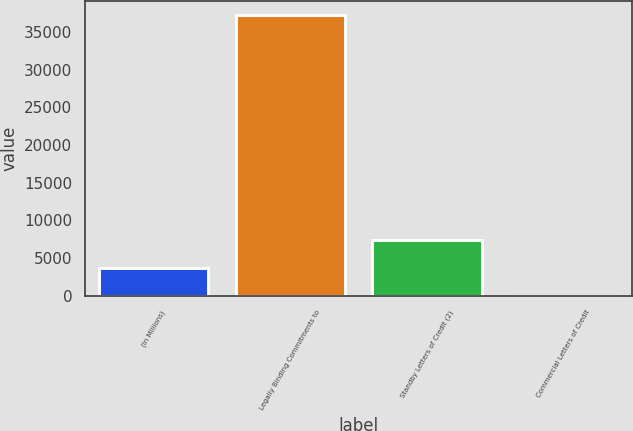<chart> <loc_0><loc_0><loc_500><loc_500><bar_chart><fcel>(In Millions)<fcel>Legally Binding Commitments to<fcel>Standby Letters of Credit (2)<fcel>Commercial Letters of Credit<nl><fcel>3740.18<fcel>37247<fcel>7463.16<fcel>17.2<nl></chart> 